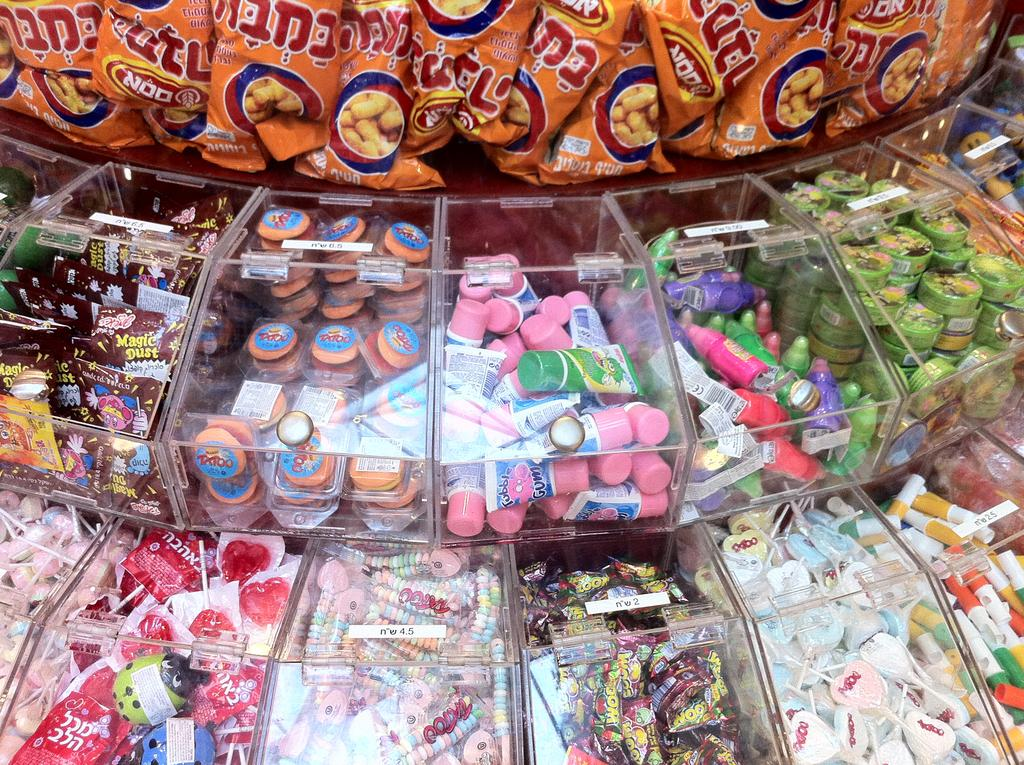What type of food items are in the boxes in the image? There are confectionery in boxes in the image. Can you describe any other snack visible in the image? Yes, there is a chips visible at the top of the image. What color is the eye of the attraction in the image? There is no attraction or eye present in the image; it only features confectionery in boxes and chips. 